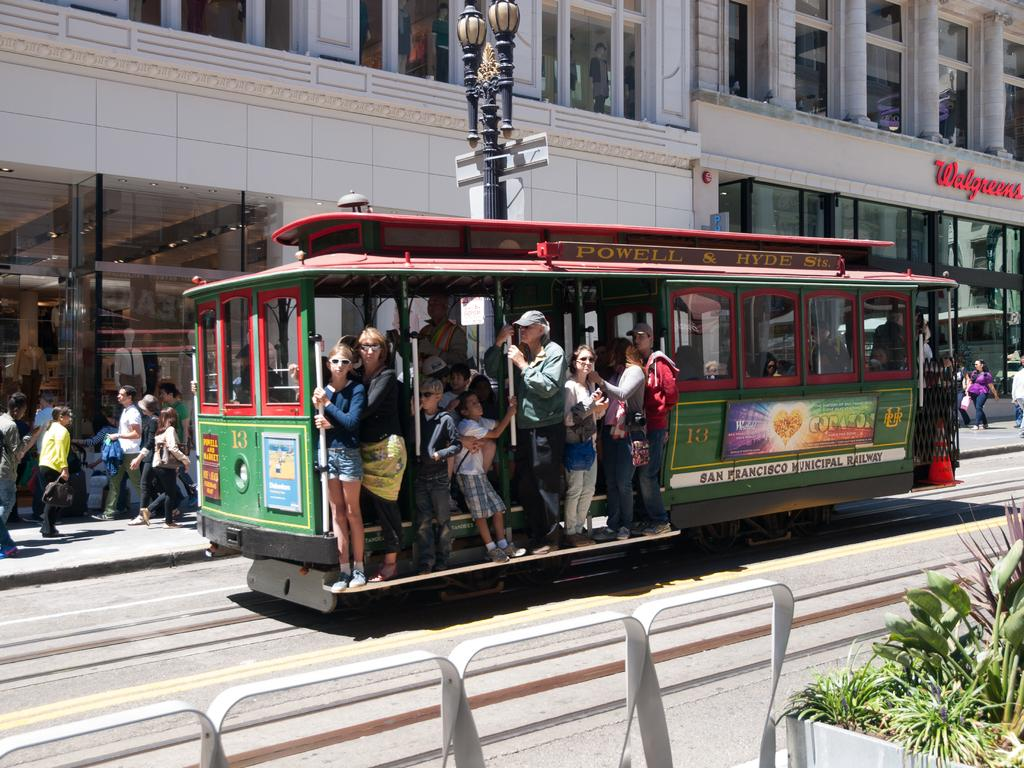<image>
Share a concise interpretation of the image provided. San Francisco runs a system of street trolleys. 